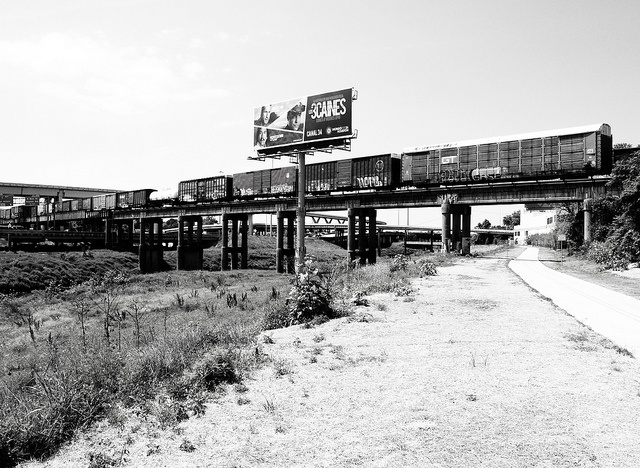Describe the objects in this image and their specific colors. I can see a train in whitesmoke, black, gray, darkgray, and lightgray tones in this image. 